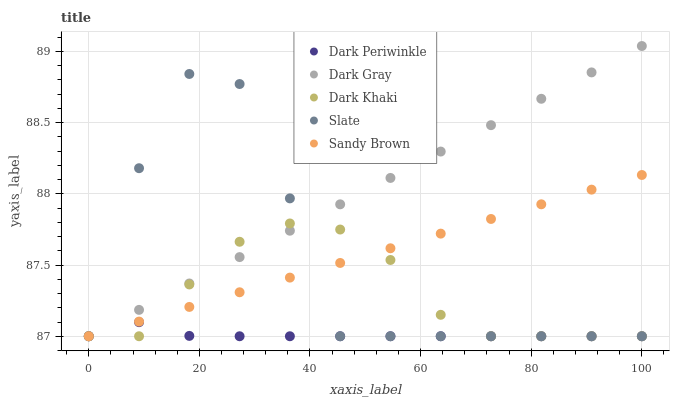Does Dark Periwinkle have the minimum area under the curve?
Answer yes or no. Yes. Does Dark Gray have the maximum area under the curve?
Answer yes or no. Yes. Does Dark Khaki have the minimum area under the curve?
Answer yes or no. No. Does Dark Khaki have the maximum area under the curve?
Answer yes or no. No. Is Dark Gray the smoothest?
Answer yes or no. Yes. Is Slate the roughest?
Answer yes or no. Yes. Is Dark Khaki the smoothest?
Answer yes or no. No. Is Dark Khaki the roughest?
Answer yes or no. No. Does Dark Gray have the lowest value?
Answer yes or no. Yes. Does Dark Gray have the highest value?
Answer yes or no. Yes. Does Dark Khaki have the highest value?
Answer yes or no. No. Does Dark Khaki intersect Dark Gray?
Answer yes or no. Yes. Is Dark Khaki less than Dark Gray?
Answer yes or no. No. Is Dark Khaki greater than Dark Gray?
Answer yes or no. No. 